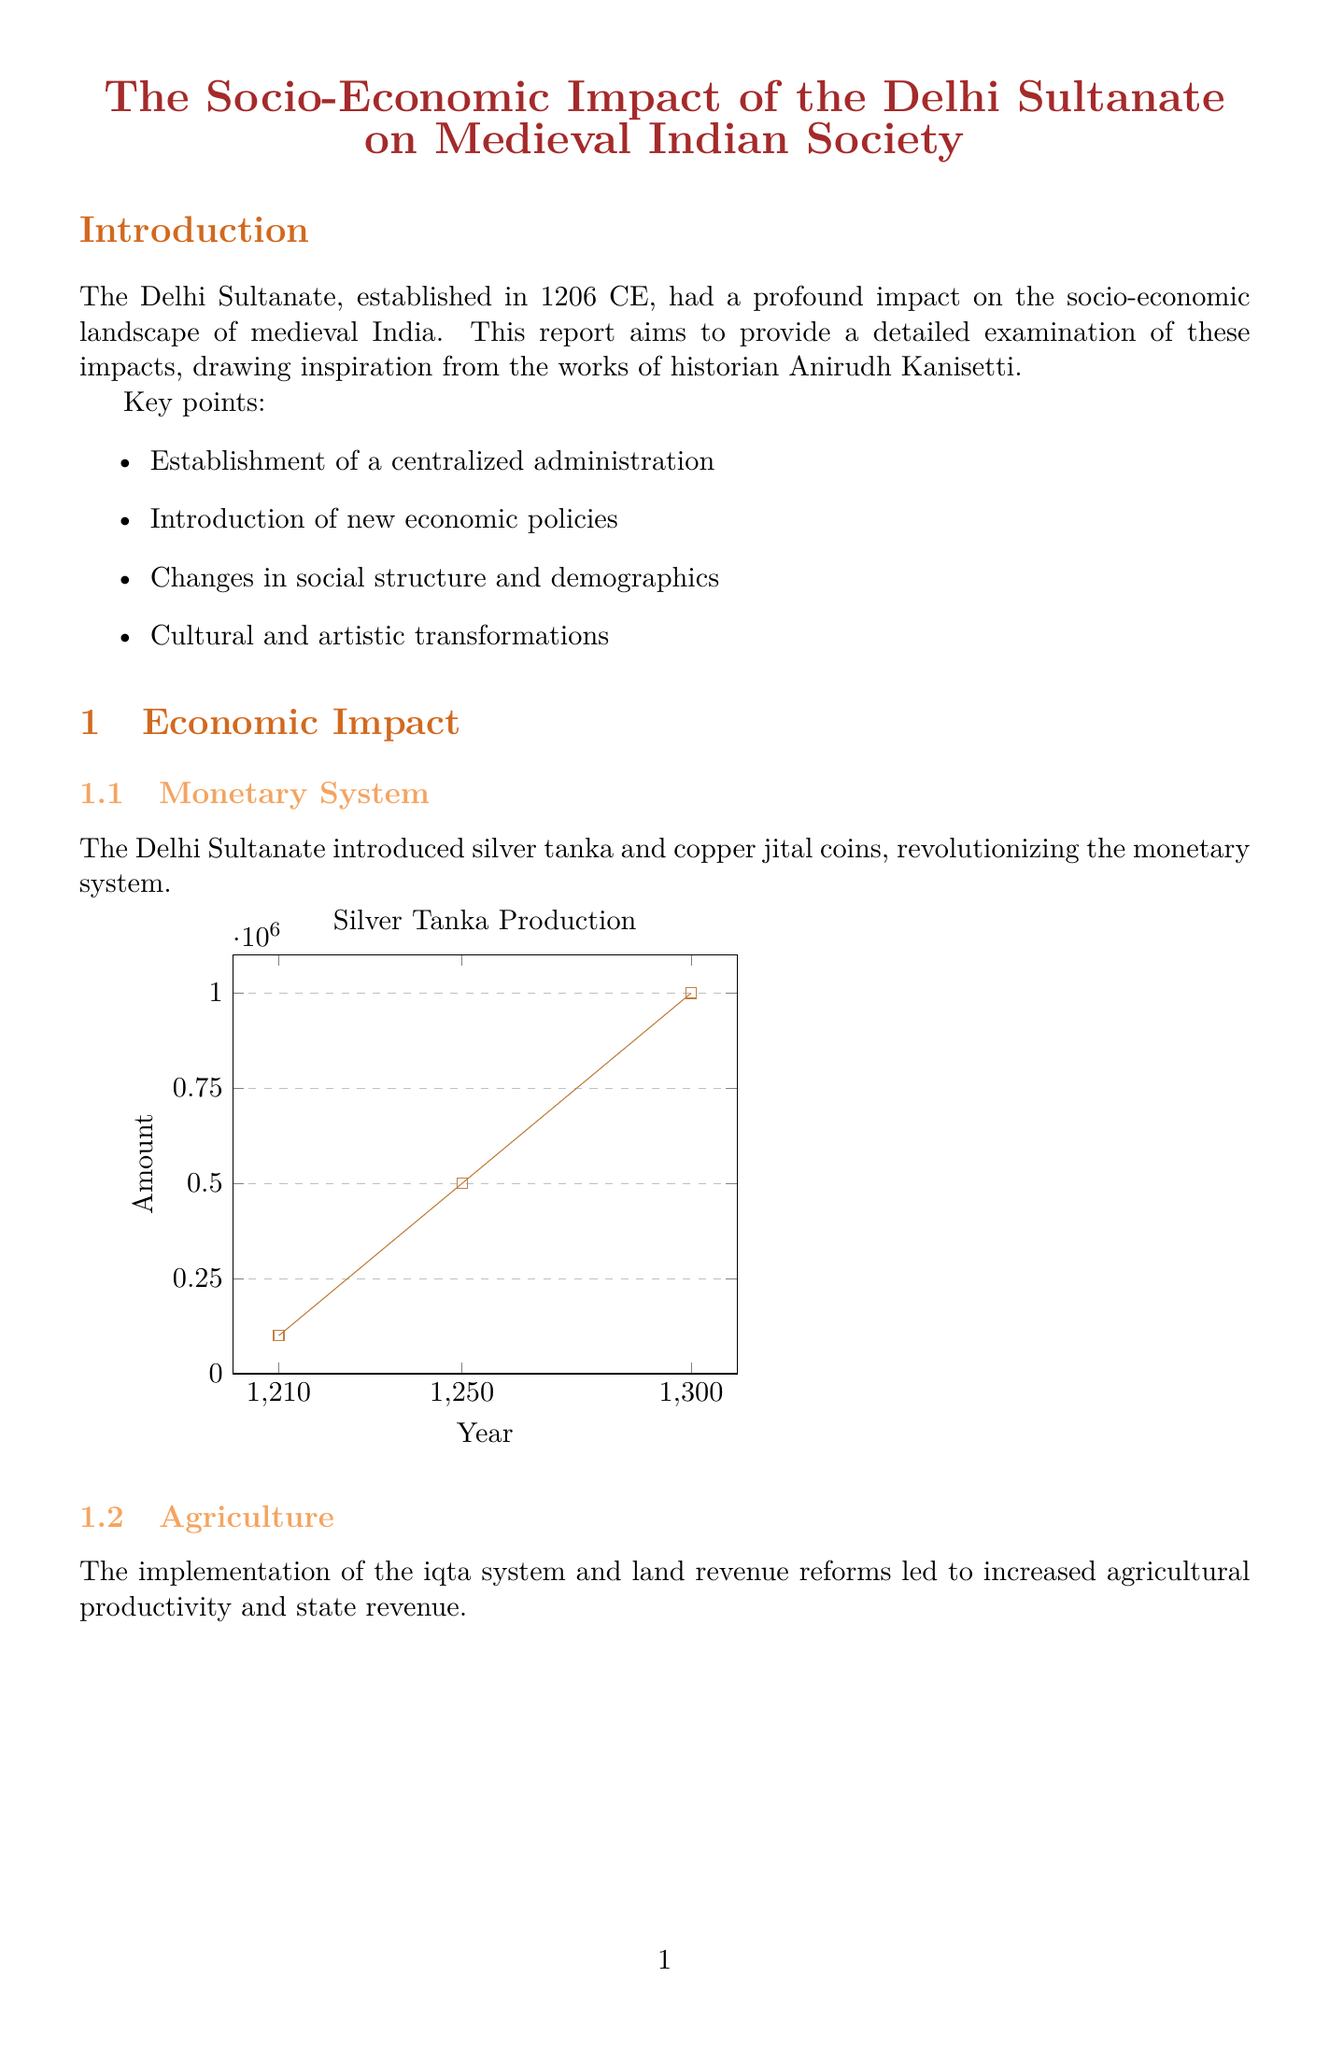What year was the Delhi Sultanate established? The report states that the Delhi Sultanate was established in 1206 CE.
Answer: 1206 CE What was the trade volume in 1300? The document provides data showing that the trade volume in 1300 was 5000000.
Answer: 5000000 Which two famous madrasas are mentioned in the document? The document lists Firozshah's madrasa in Delhi and Qutbuddin Aibak's madrasa in Lahore as famous institutions.
Answer: Firozshah's madrasa, Qutbuddin Aibak's madrasa What percentage of urban population was recorded in 1250? The data shows that the urban population percentage in 1250 was 15.
Answer: 15 What impact did the introduction of Persian as a court language have? The report mentions that Persian's introduction led to the development of Urdu as a syncretic language.
Answer: Development of Urdu How many new social classes emerged during the Sultanate? The document outlines the emergence of three new social classes: Administrative elite, Military nobility, and Merchant class.
Answer: Three What are the main features of Indo-Islamic architecture? The report lists use of arches, domes, and decorative calligraphy as key features.
Answer: Arches, domes, decorative calligraphy What was the land revenue collection amount in 1200? The document states that the land revenue collection in 1200 was 5000000.
Answer: 5000000 In what year did the production of silver tanka reach 1000000? According to the document, silver tanka production reached 1000000 in 1300.
Answer: 1300 